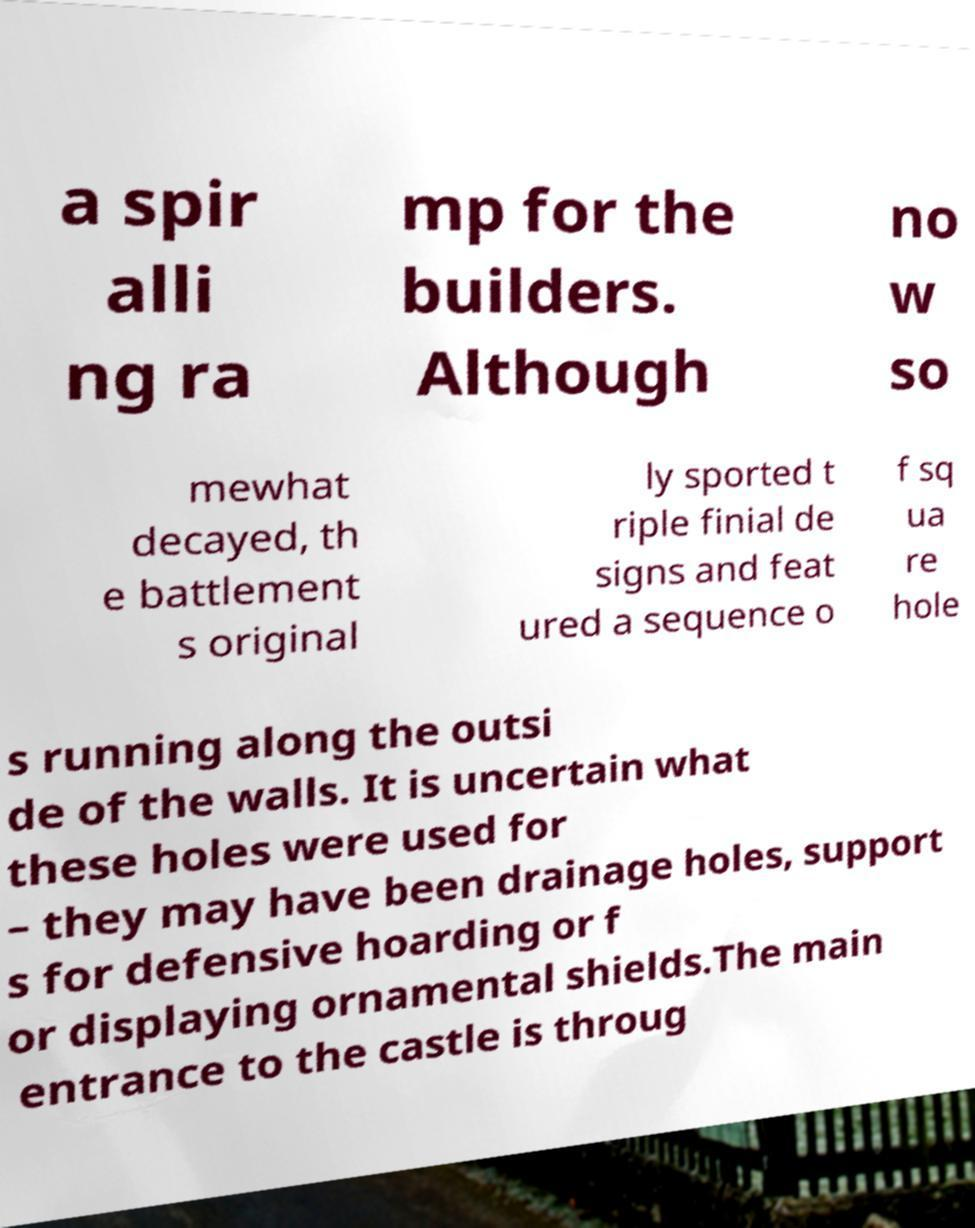For documentation purposes, I need the text within this image transcribed. Could you provide that? a spir alli ng ra mp for the builders. Although no w so mewhat decayed, th e battlement s original ly sported t riple finial de signs and feat ured a sequence o f sq ua re hole s running along the outsi de of the walls. It is uncertain what these holes were used for – they may have been drainage holes, support s for defensive hoarding or f or displaying ornamental shields.The main entrance to the castle is throug 